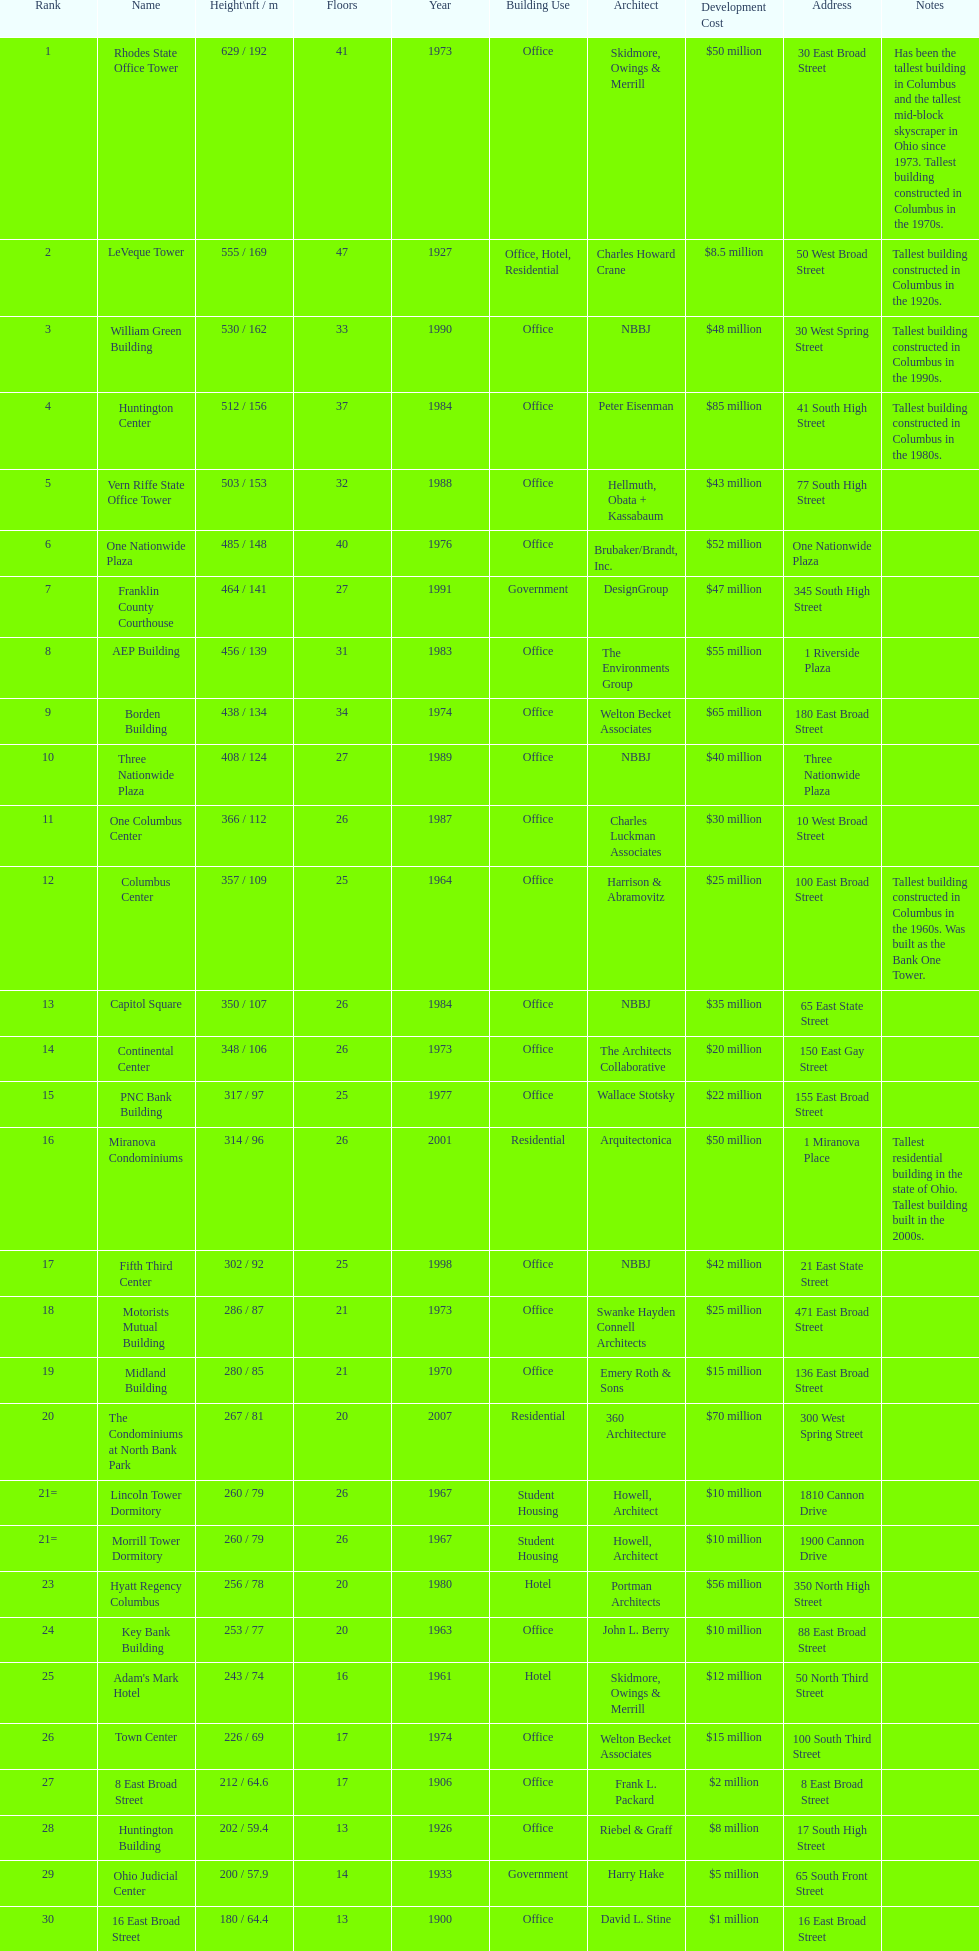How many buildings on this table are taller than 450 feet? 8. 